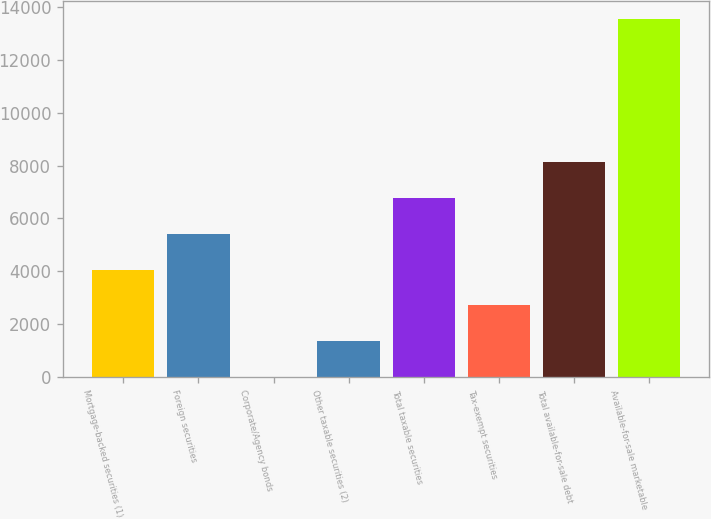Convert chart. <chart><loc_0><loc_0><loc_500><loc_500><bar_chart><fcel>Mortgage-backed securities (1)<fcel>Foreign securities<fcel>Corporate/Agency bonds<fcel>Other taxable securities (2)<fcel>Total taxable securities<fcel>Tax-exempt securities<fcel>Total available-for-sale debt<fcel>Available-for-sale marketable<nl><fcel>4060.4<fcel>5413.2<fcel>2<fcel>1354.8<fcel>6766<fcel>2707.6<fcel>8118.8<fcel>13530<nl></chart> 